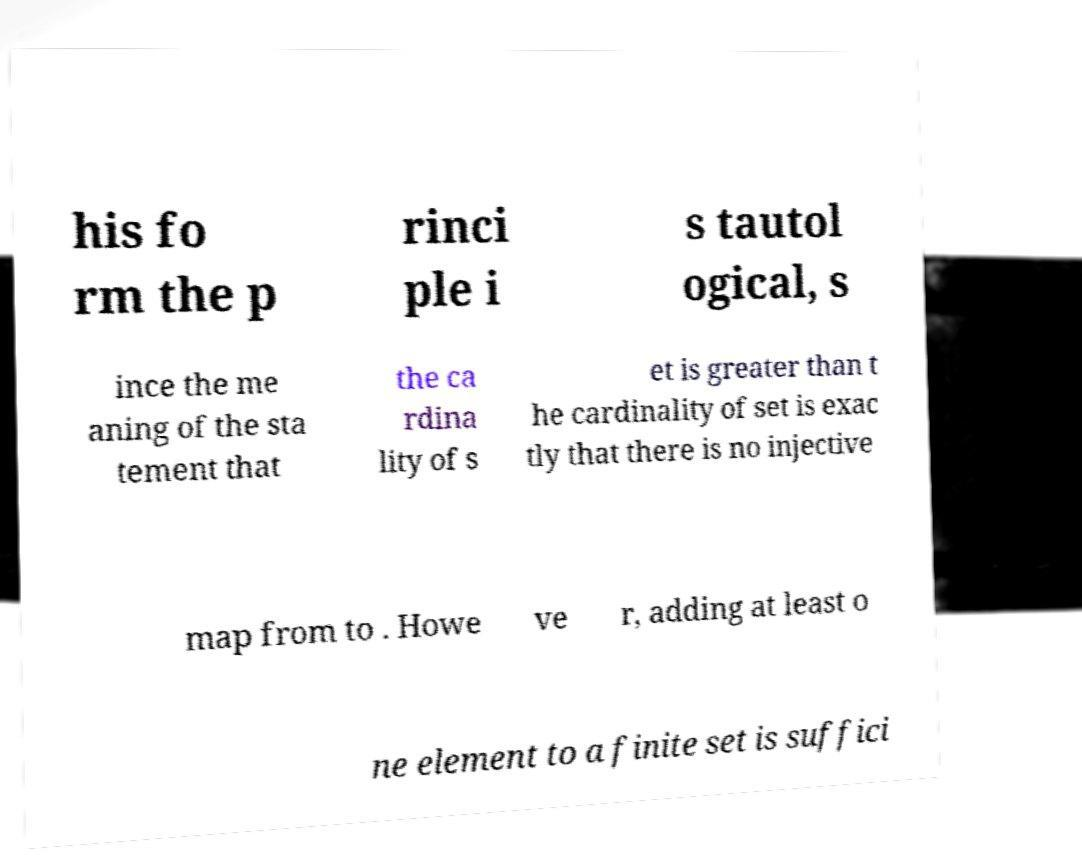Can you read and provide the text displayed in the image?This photo seems to have some interesting text. Can you extract and type it out for me? his fo rm the p rinci ple i s tautol ogical, s ince the me aning of the sta tement that the ca rdina lity of s et is greater than t he cardinality of set is exac tly that there is no injective map from to . Howe ve r, adding at least o ne element to a finite set is suffici 